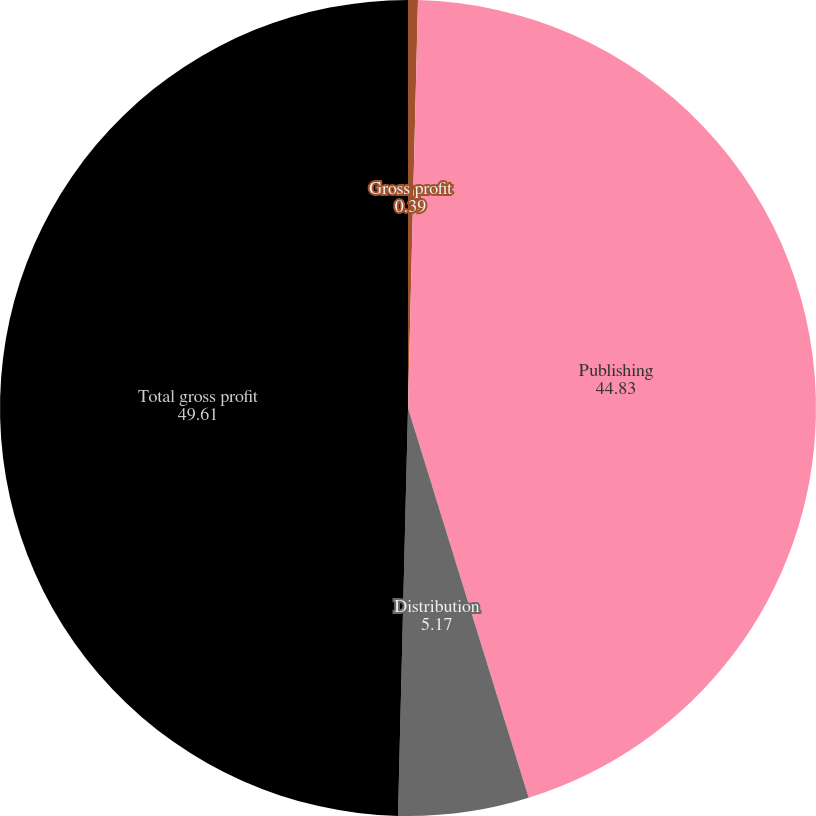<chart> <loc_0><loc_0><loc_500><loc_500><pie_chart><fcel>Gross profit<fcel>Publishing<fcel>Distribution<fcel>Total gross profit<nl><fcel>0.39%<fcel>44.83%<fcel>5.17%<fcel>49.61%<nl></chart> 